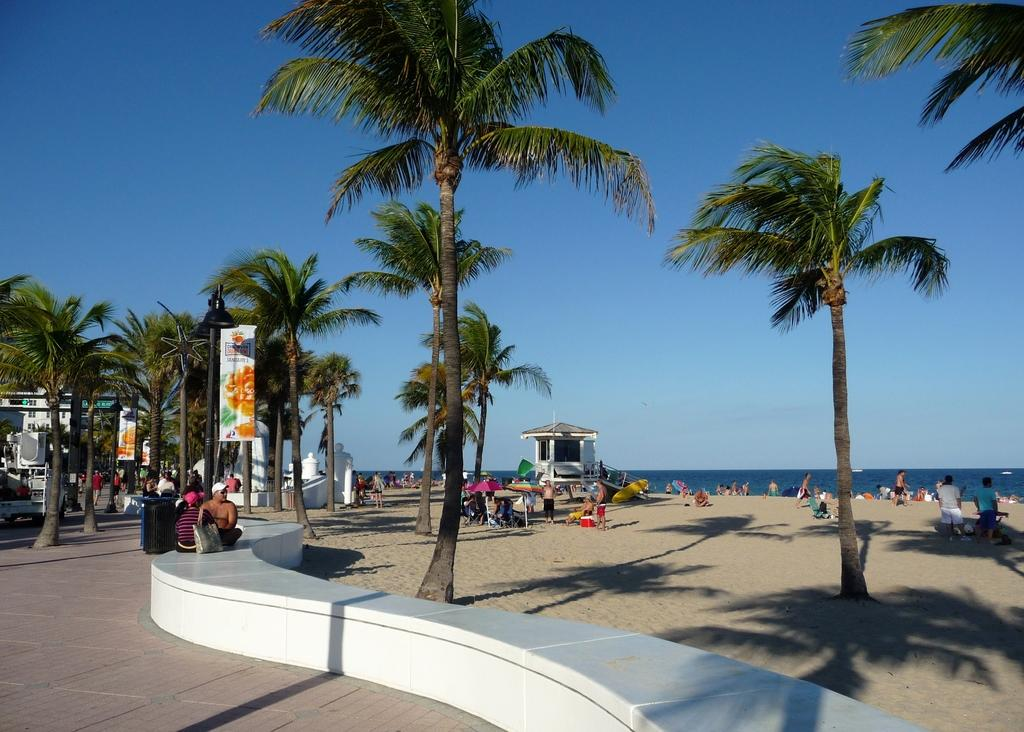What is located in the center of the image? There are trees in the center of the image. What type of surface can be seen in the image? There is a pavement in the image. Are there any living beings present in the image? Yes, there are people in the image. What can be seen in the background of the image? There is sky visible in the background of the image. What natural elements are present in the image? There is water and sand in the image. Can you see any cheese in the image? There is no cheese present in the image. Are the people in the image kissing? The provided facts do not mention any kissing or romantic interactions between the people in the image. --- Facts: 1. There is a car in the image. 2. The car is red. 3. The car has four wheels. 4. There are people in the car. 5. The car has a roof. Absurd Topics: parrot, ocean, dance Conversation: 